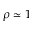Convert formula to latex. <formula><loc_0><loc_0><loc_500><loc_500>\rho \simeq 1</formula> 